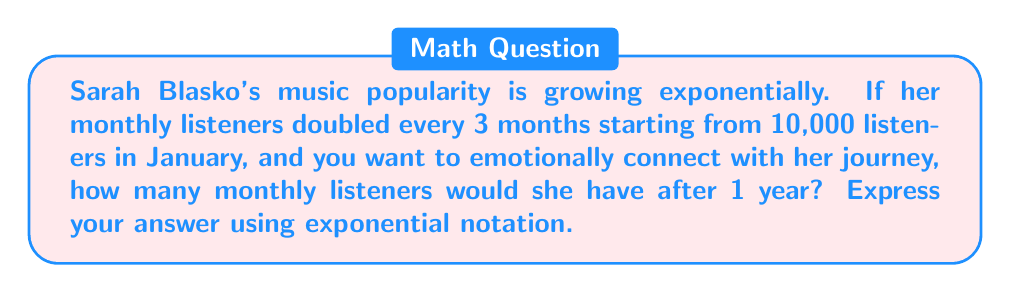Provide a solution to this math problem. Let's approach this step-by-step:

1) We start with the initial number of listeners: $N_0 = 10,000$

2) The growth rate is doubling (multiplying by 2) every 3 months.

3) In one year, there are 4 periods of 3 months each.

4) We can model this with the exponential function:
   $N(t) = N_0 \cdot 2^t$
   Where $t$ is the number of 3-month periods.

5) After 1 year, $t = 4$, so we calculate:
   $N(4) = 10,000 \cdot 2^4$

6) Simplify:
   $N(4) = 10,000 \cdot 16 = 160,000$

7) Express in exponential notation:
   $160,000 = 1.6 \times 10^5$

This exponential growth reflects the emotional journey of connecting with an artist whose popularity is rapidly increasing.
Answer: $1.6 \times 10^5$ listeners 